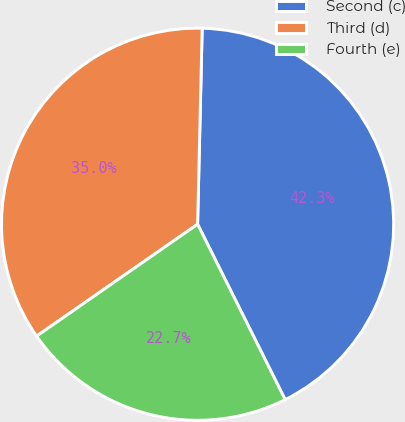Convert chart to OTSL. <chart><loc_0><loc_0><loc_500><loc_500><pie_chart><fcel>Second (c)<fcel>Third (d)<fcel>Fourth (e)<nl><fcel>42.26%<fcel>35.04%<fcel>22.7%<nl></chart> 